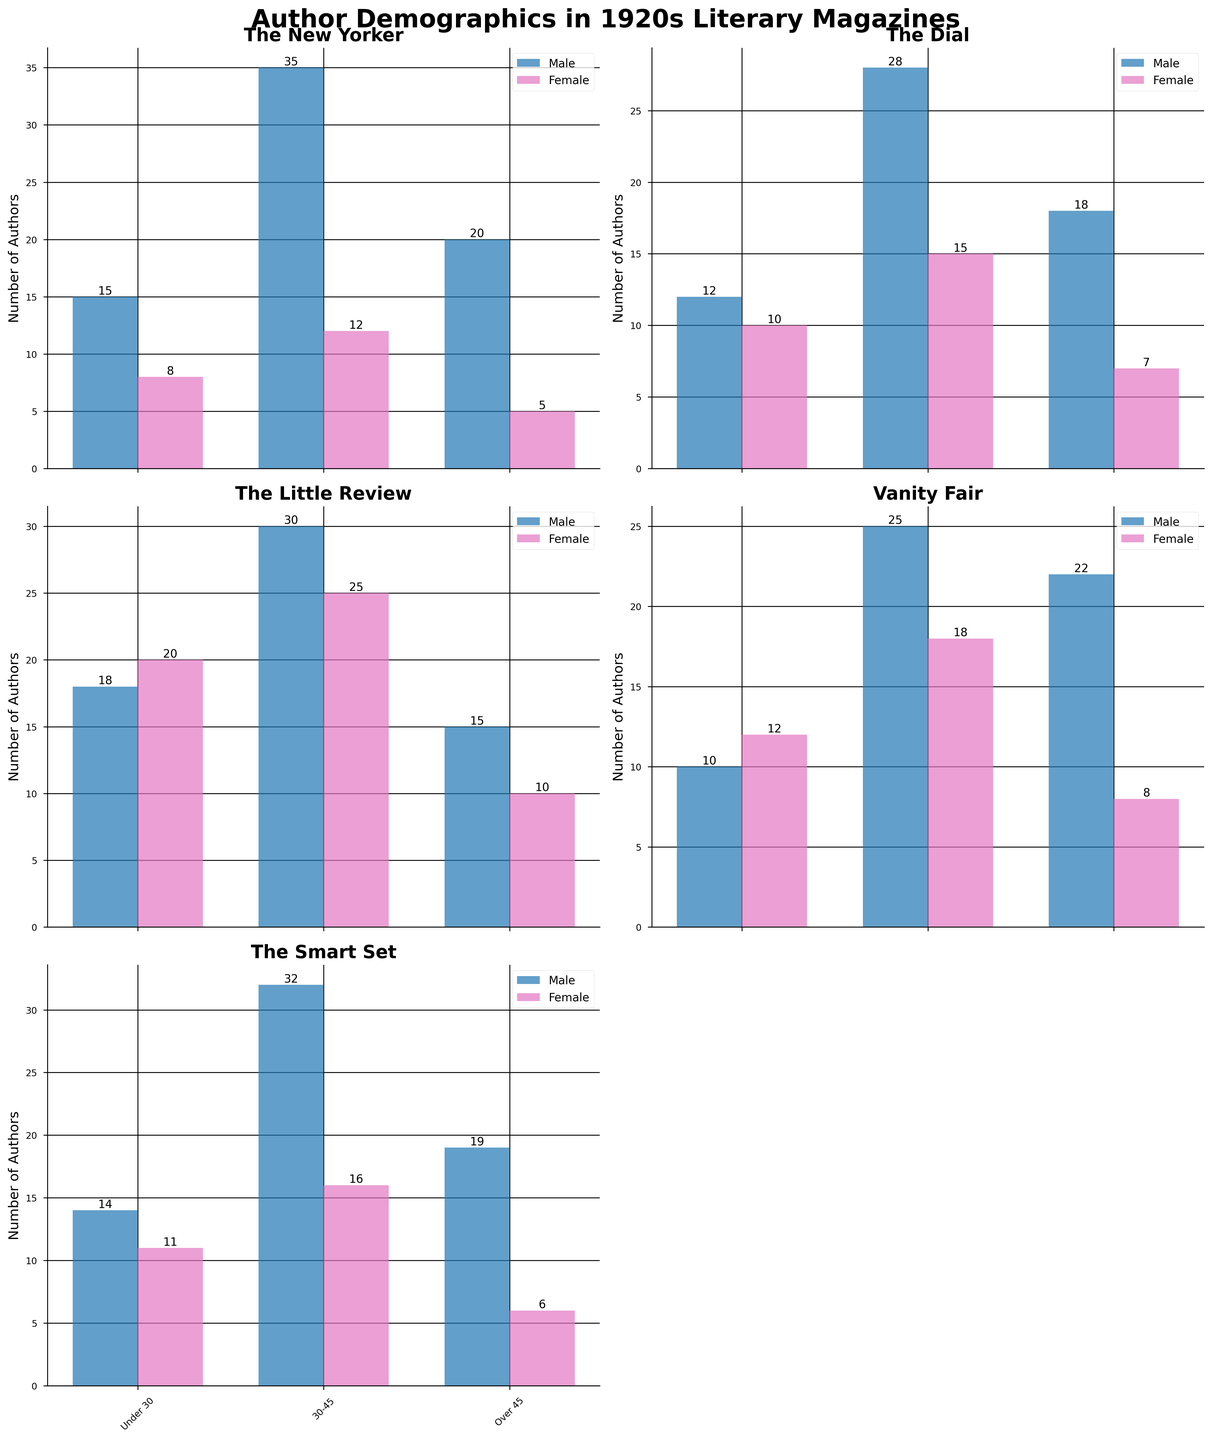What is the title of the figure? The title is usually located at the top of the figure. The figure title is "Author Demographics in 1920s Literary Magazines".
Answer: Author Demographics in 1920s Literary Magazines How many total male authors under 30 were published in The New Yorker? Looking at the subplot for The New Yorker, the bar for male authors under 30 indicates the number 15.
Answer: 15 Which magazine has the highest number of female authors aged 30-45? Examine each subplot for the female authors aged 30-45 and identify the tallest bar. The Little Review has the highest number with 25.
Answer: The Little Review Compare the number of male and female authors in the 30-45 age group for Vanity Fair. Which gender has more authors, and by how much? Look at the bars for Vanity Fair in the 30-45 age group: Male authors are 25 and female authors are 18. Subtract the number of female authors from the number of male authors (25 - 18 = 7).
Answer: Male, 7 more authors What is the total number of authors over 45 published in The Dial? Sum the number of male and female authors over 45 in The Dial subplot. Males are 18 and females are 7. The total is 18 + 7 = 25.
Answer: 25 Which age group has the smallest number of female authors in The Smart Set magazine? In the subplot for The Smart Set, compare the bars for female authors across age groups. The 'Over 45' group shows the smallest number with 6 authors.
Answer: Over 45 How many more male authors under 30 were published in The New Yorker compared to Vanity Fair? Check the subplots for male authors under 30: The New Yorker has 15 and Vanity Fair has 10. Calculate the difference (15 - 10 = 5).
Answer: 5 In The Little Review, what is the difference in the number of female authors between the 30-45 and Under 30 age groups? Examine the subplot for The Little Review, focusing on female authors. Females aged 30-45 are 25 and those under 30 are 20. Subtract the under 30 value from the 30-45 value (25 - 20 = 5).
Answer: 5 Which magazine has the equal number of male and female authors in the Over 45 age group? Look at each subplot; The New Yorker shows 20 male and 5 female authors and so on, until you find the subgroup where male and female authors are equal. None of the magazines have equal male and female authors in the Over 45 age group.
Answer: None What is the total number of authors aged 30-45 published in The Smart Set? Sum the male and female authors in the 30-45 age group for The Smart Set. Males are 32 and females are 16. The total is 32 + 16 = 48.
Answer: 48 